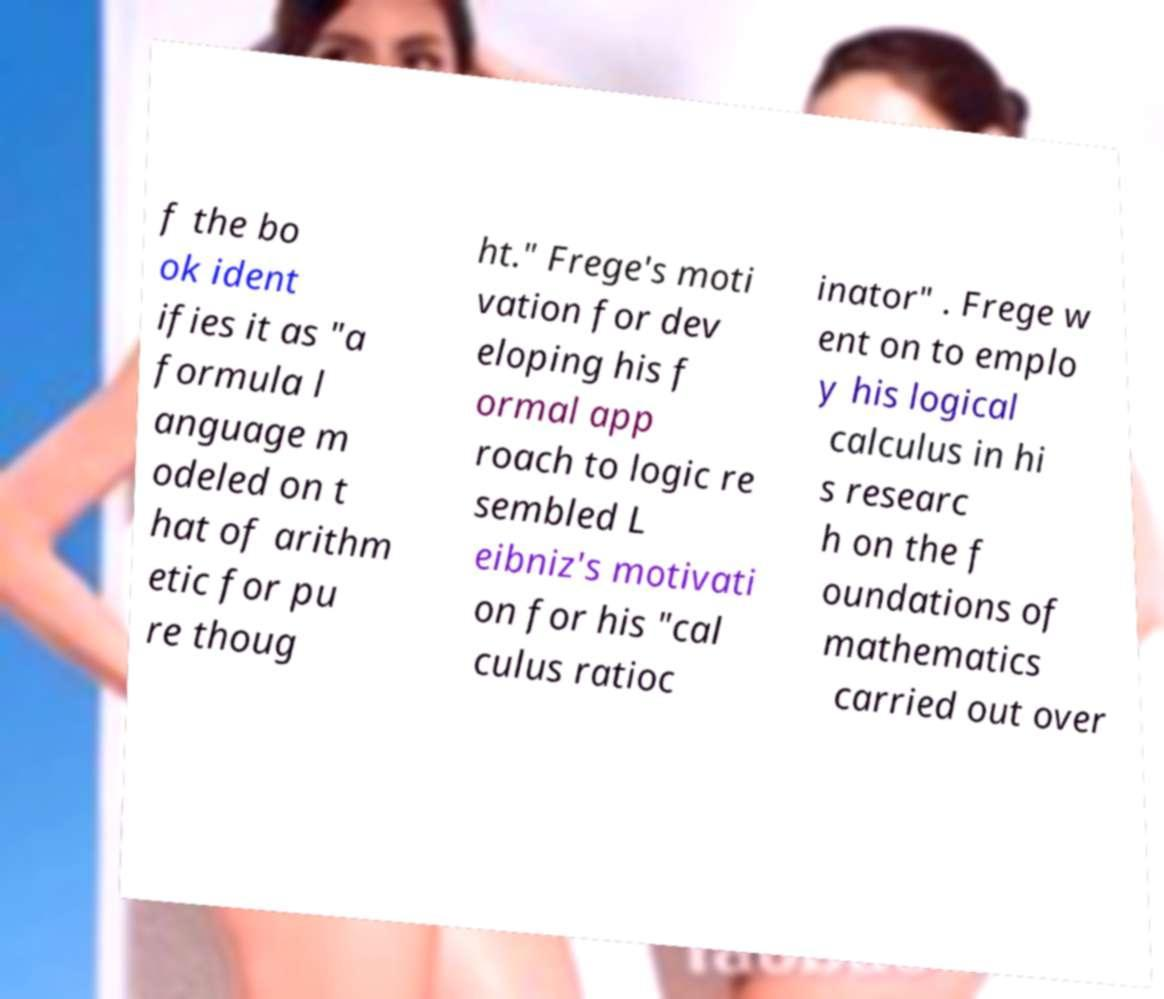Could you extract and type out the text from this image? f the bo ok ident ifies it as "a formula l anguage m odeled on t hat of arithm etic for pu re thoug ht." Frege's moti vation for dev eloping his f ormal app roach to logic re sembled L eibniz's motivati on for his "cal culus ratioc inator" . Frege w ent on to emplo y his logical calculus in hi s researc h on the f oundations of mathematics carried out over 